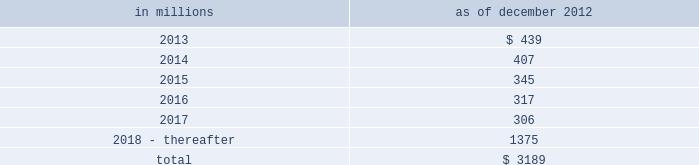Notes to consolidated financial statements sumitomo mitsui financial group , inc .
( smfg ) provides the firm with credit loss protection on certain approved loan commitments ( primarily investment-grade commercial lending commitments ) .
The notional amount of such loan commitments was $ 32.41 billion and $ 31.94 billion as of december 2012 and december 2011 , respectively .
The credit loss protection on loan commitments provided by smfg is generally limited to 95% ( 95 % ) of the first loss the firm realizes on such commitments , up to a maximum of approximately $ 950 million .
In addition , subject to the satisfaction of certain conditions , upon the firm 2019s request , smfg will provide protection for 70% ( 70 % ) of additional losses on such commitments , up to a maximum of $ 1.13 billion , of which $ 300 million of protection had been provided as of both december 2012 and december 2011 .
The firm also uses other financial instruments to mitigate credit risks related to certain commitments not covered by smfg .
These instruments primarily include credit default swaps that reference the same or similar underlying instrument or entity or credit default swaps that reference a market index .
Warehouse financing .
The firm provides financing to clients who warehouse financial assets .
These arrangements are secured by the warehoused assets , primarily consisting of commercial mortgage loans .
Contingent and forward starting resale and securities borrowing agreements/forward starting repurchase and secured lending agreements the firm enters into resale and securities borrowing agreements and repurchase and secured lending agreements that settle at a future date .
The firm also enters into commitments to provide contingent financing to its clients and counterparties through resale agreements .
The firm 2019s funding of these commitments depends on the satisfaction of all contractual conditions to the resale agreement and these commitments can expire unused .
Investment commitments the firm 2019s investment commitments consist of commitments to invest in private equity , real estate and other assets directly and through funds that the firm raises and manages .
These commitments include $ 872 million and $ 1.62 billion as of december 2012 and december 2011 , respectively , related to real estate private investments and $ 6.47 billion and $ 7.50 billion as of december 2012 and december 2011 , respectively , related to corporate and other private investments .
Of these amounts , $ 6.21 billion and $ 8.38 billion as of december 2012 and december 2011 , respectively , relate to commitments to invest in funds managed by the firm , which will be funded at market value on the date of investment .
Leases the firm has contractual obligations under long-term noncancelable lease agreements , principally for office space , expiring on various dates through 2069 .
Certain agreements are subject to periodic escalation provisions for increases in real estate taxes and other charges .
The table below presents future minimum rental payments , net of minimum sublease rentals .
In millions december 2012 .
Rent charged to operating expense for the years ended december 2012 , december 2011 and december 2010 was $ 374 million , $ 475 million and $ 508 million , respectively .
Operating leases include office space held in excess of current requirements .
Rent expense relating to space held for growth is included in 201coccupancy . 201d the firm records a liability , based on the fair value of the remaining lease rentals reduced by any potential or existing sublease rentals , for leases where the firm has ceased using the space and management has concluded that the firm will not derive any future economic benefits .
Costs to terminate a lease before the end of its term are recognized and measured at fair value on termination .
Goldman sachs 2012 annual report 175 .
In billions as of december 2012 and december 2011 , what was the average amount of commitments to invest in funds managed by the firm , which will be funded at market value on the date of investment? 
Computations: ((6.21 + 8.38) / 2)
Answer: 7.295. 